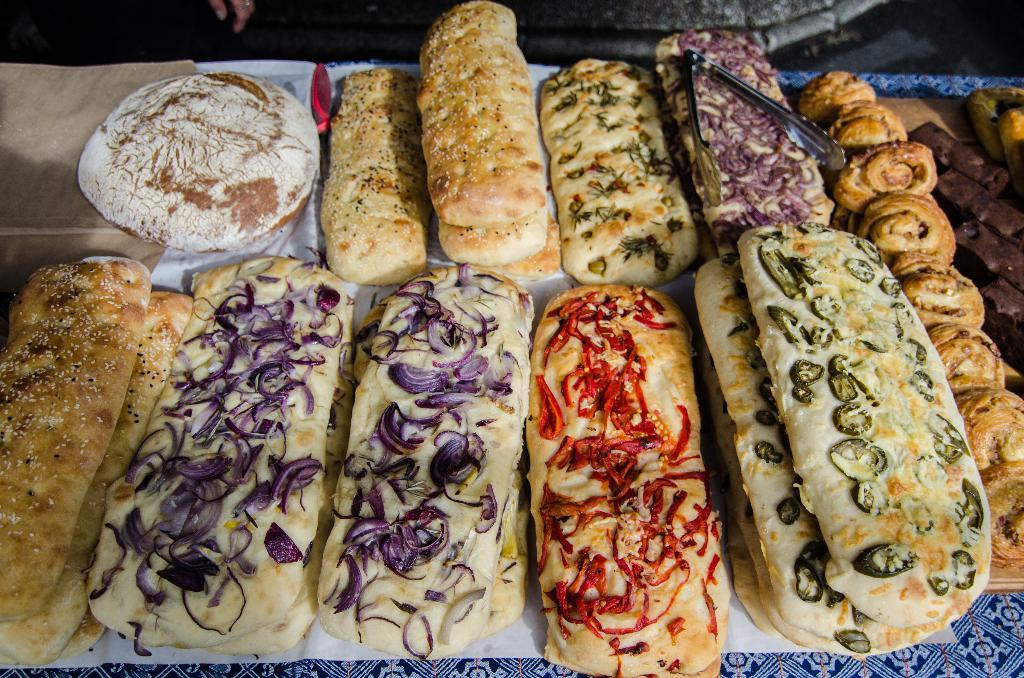What type of furniture is in the image? There is a table in the image. What is on top of the table? Papers and food items are present on the table. What is used to hold something on the table? There is a holder on the table. What part of the room can be seen at the top of the image? The floor is visible at the top of the image. Whose hand is visible in the image? A person's hand is present in the image. What type of insurance policy is being discussed in the image? There is no mention of insurance or any discussion in the image; it primarily features a table with various items on it. 